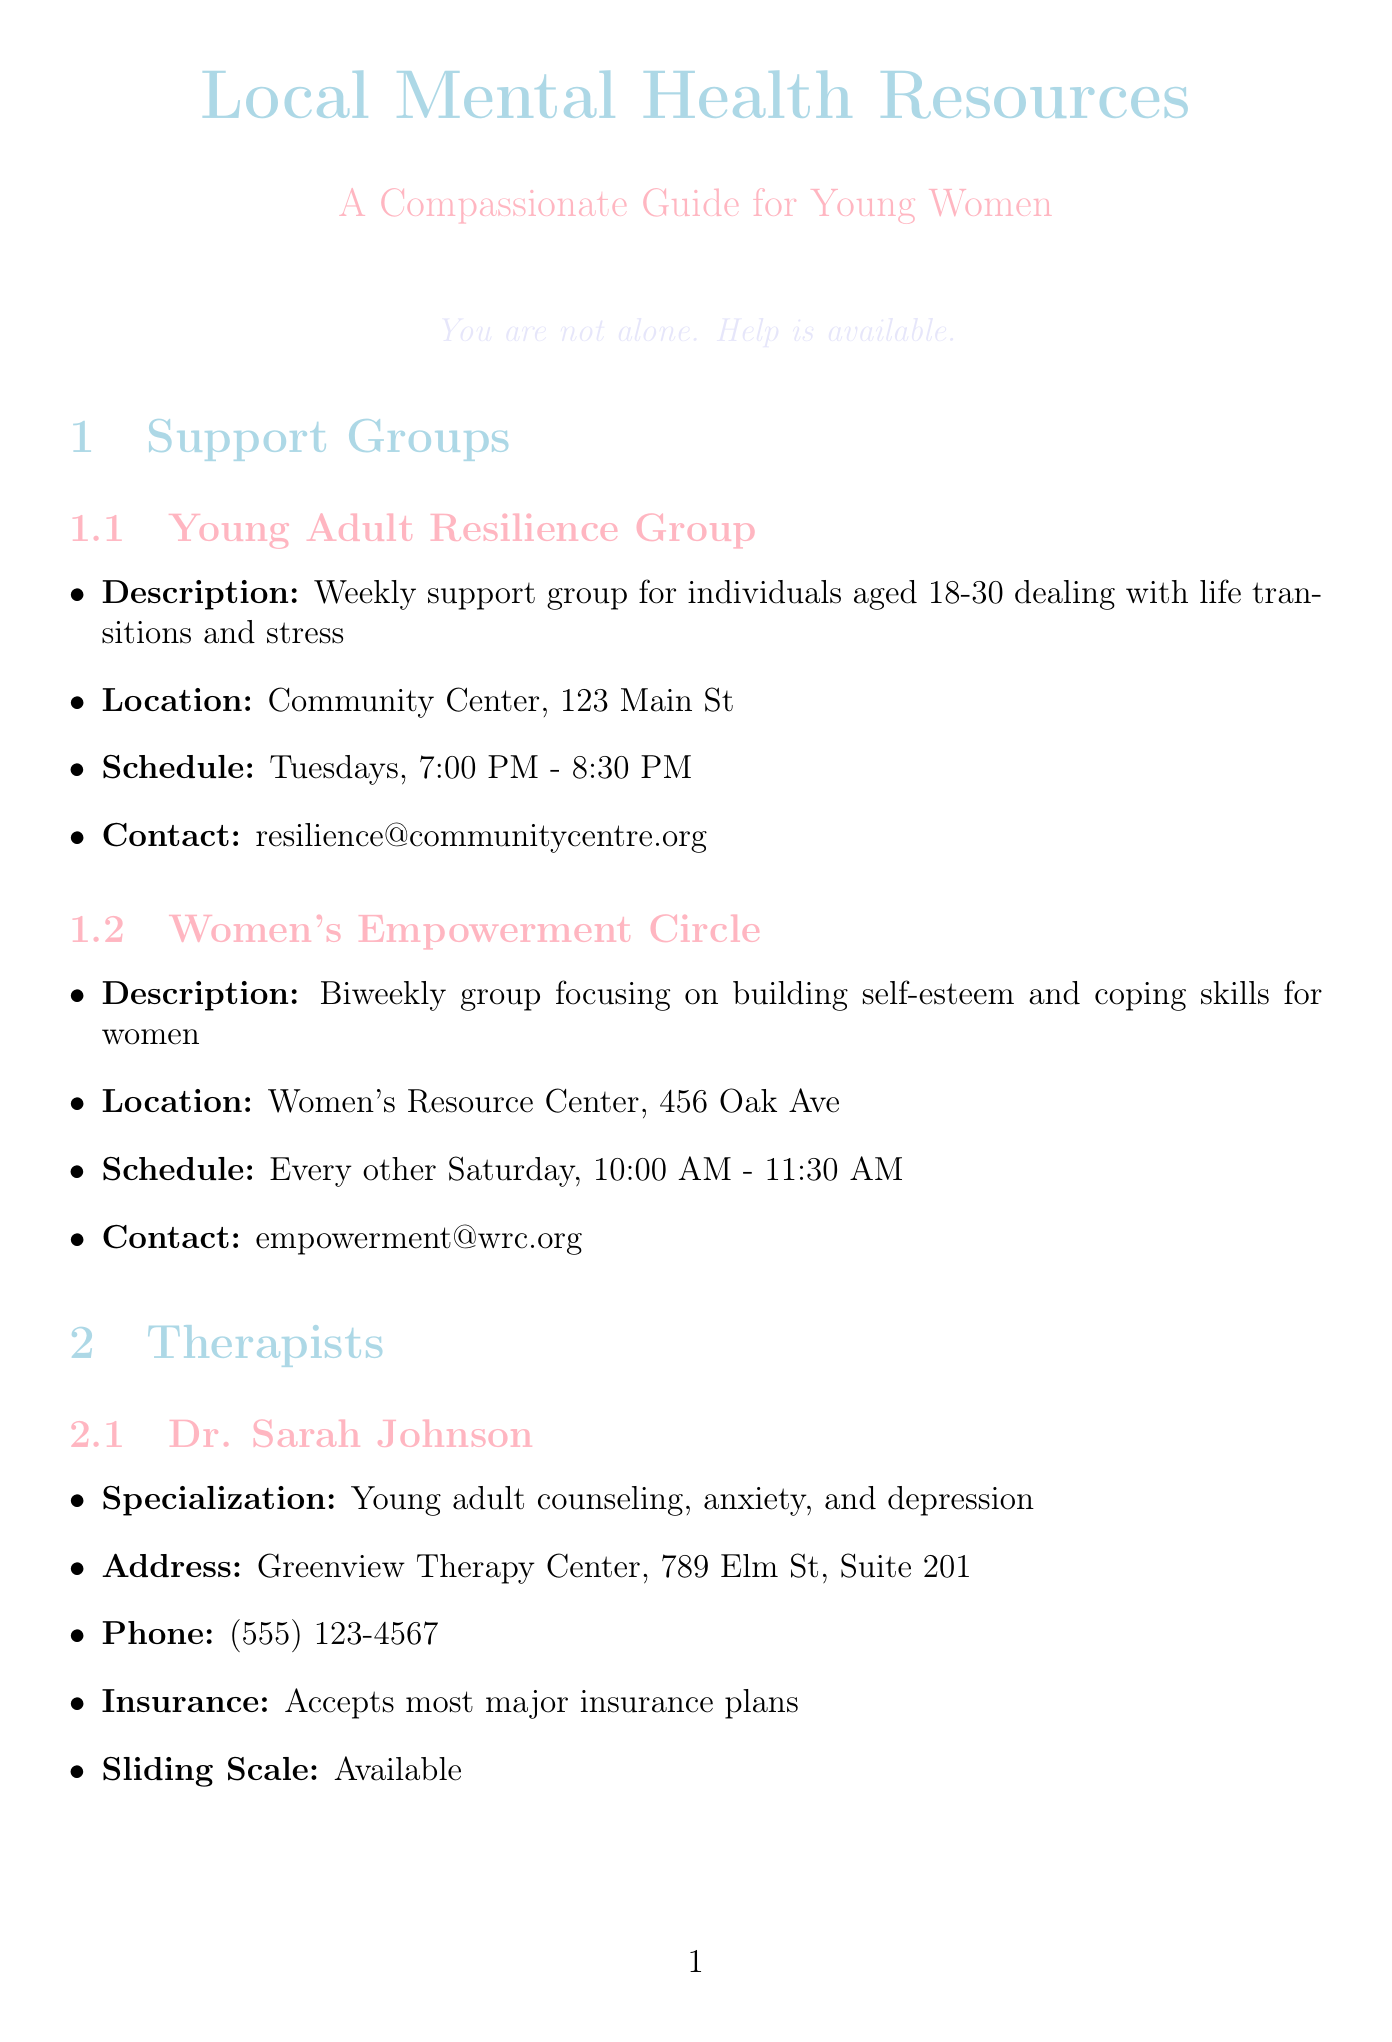What is the location of the Young Adult Resilience Group? The location is listed within the support group section as "Community Center, 123 Main St."
Answer: Community Center, 123 Main St How often does the Women's Empowerment Circle meet? The schedule indicates it meets "Every other Saturday."
Answer: Every other Saturday What is Dr. Sarah Johnson's specialization? The specialization is noted in the therapist section as "Young adult counseling, anxiety, and depression."
Answer: Young adult counseling, anxiety, and depression What service does the Local Crisis Support Line provide? The document specifies the services provided, noting "Immediate emotional support, crisis intervention, referrals."
Answer: Immediate emotional support, crisis intervention, referrals How can someone reach Lisa Martinez, LMFT? The phone number in the therapist section for Lisa Martinez is given as "(555) 987-6543."
Answer: (555) 987-6543 What type of resources does MindfulnessMoments.com offer? The description lists "Free guided meditations and stress-reduction techniques."
Answer: Free guided meditations and stress-reduction techniques When does the ArtHeals Workshop Series occur? The schedule indicates it is held "First Saturday of each month."
Answer: First Saturday of each month What is the primary focus of the Mindful Movement in the Park program? The document describes it as "Free outdoor yoga and meditation classes."
Answer: Free outdoor yoga and meditation classes What is the contact email for the Young Adult Resilience Group? The contact information in the document provides the email as "resilience@communitycentre.org."
Answer: resilience@communitycentre.org 